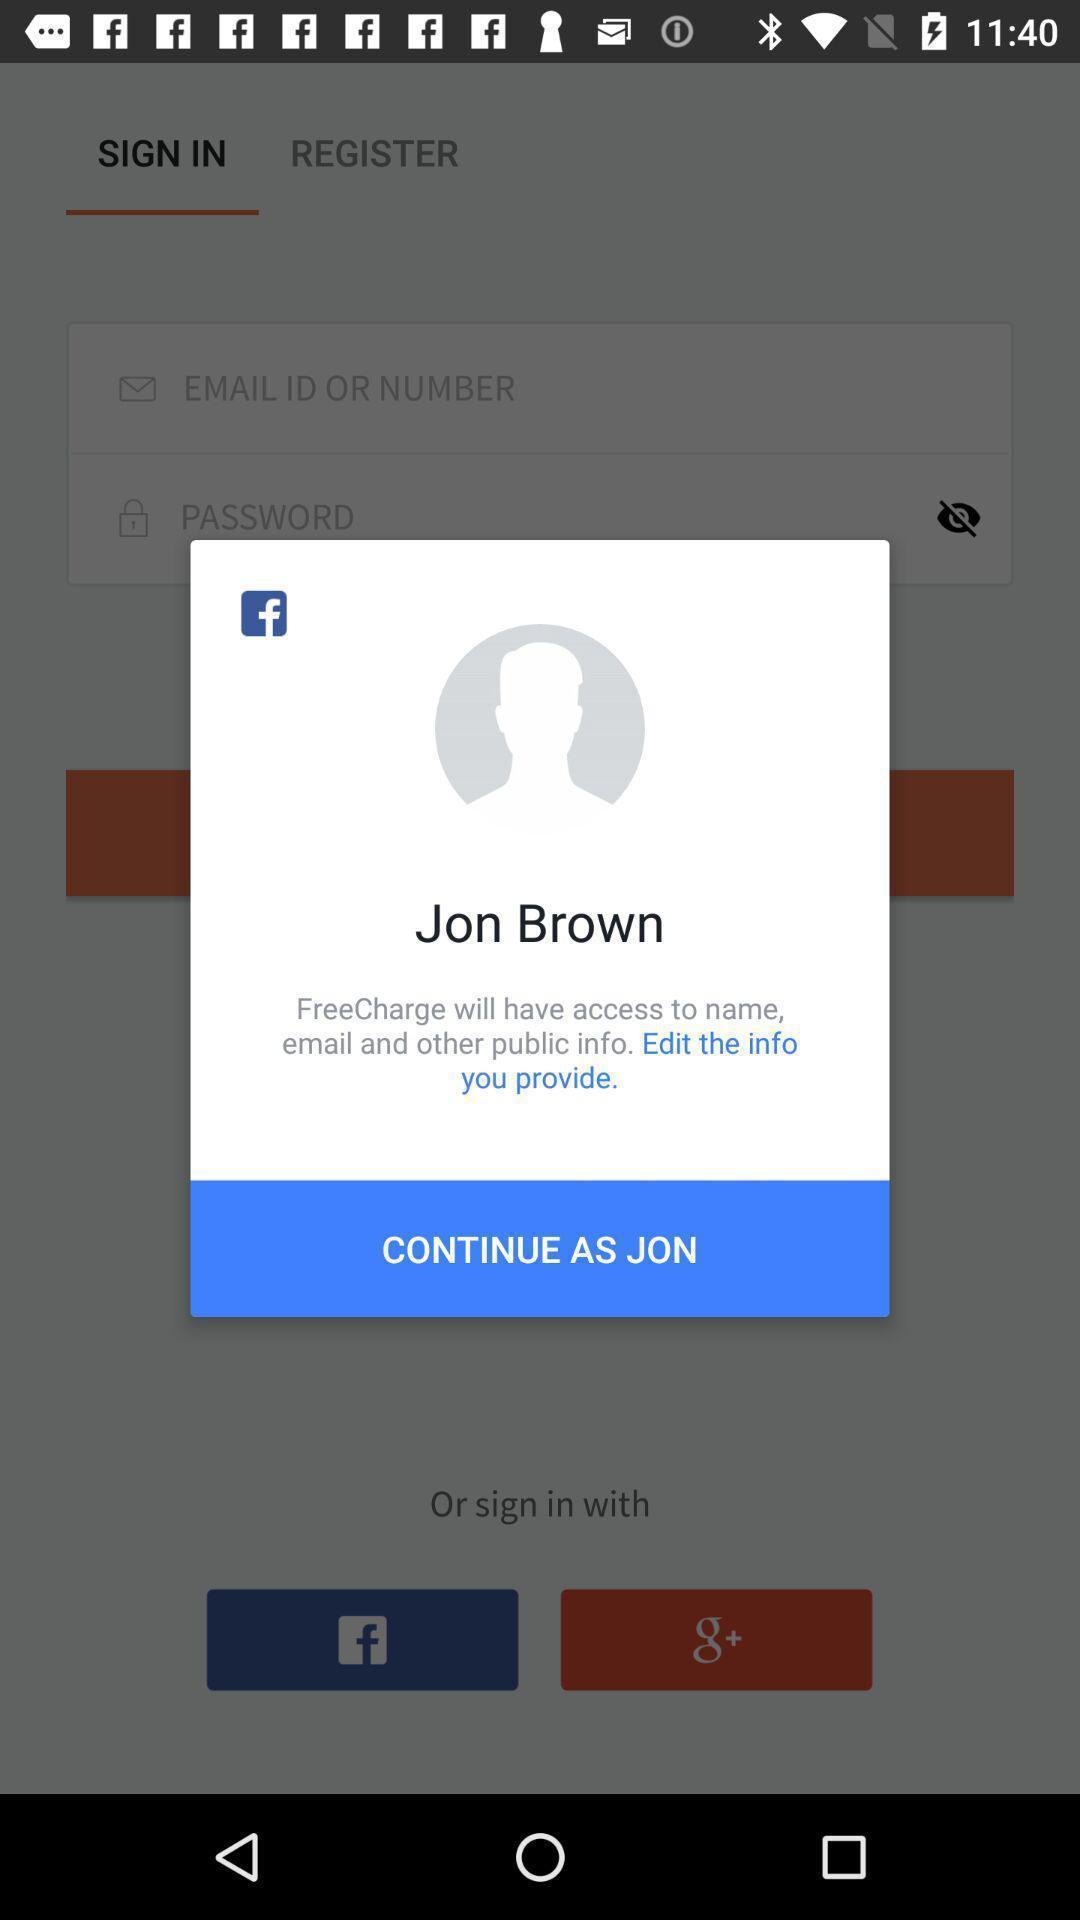Provide a detailed account of this screenshot. Pop-up shows continue. 